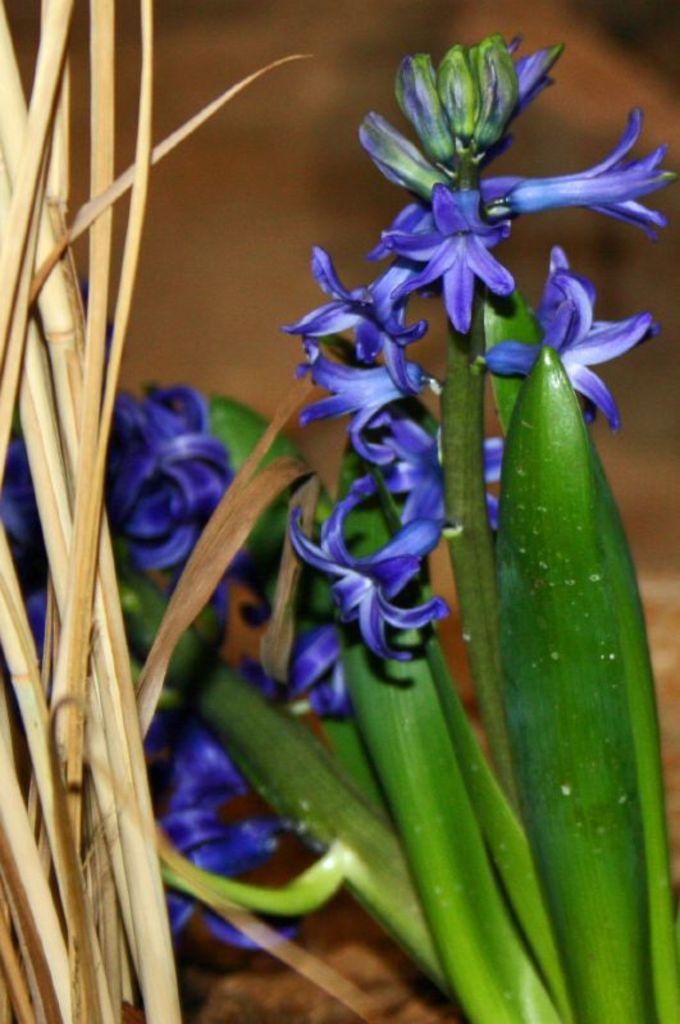How would you summarize this image in a sentence or two? There are plants having violet color flowers near other plants which are having dry leaves. And the background is blurred. 